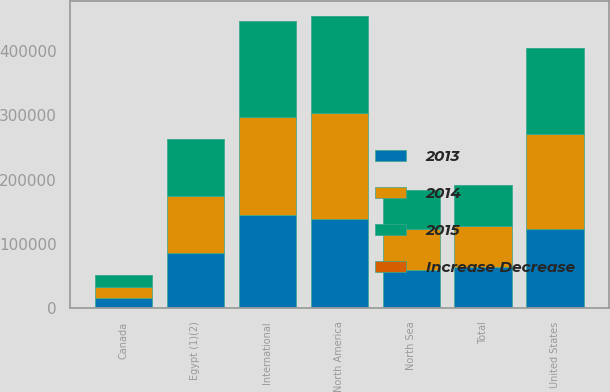<chart> <loc_0><loc_0><loc_500><loc_500><stacked_bar_chart><ecel><fcel>United States<fcel>Canada<fcel>North America<fcel>Egypt (1)(2)<fcel>North Sea<fcel>International<fcel>Total<nl><fcel>2013<fcel>123666<fcel>15768<fcel>139434<fcel>85589<fcel>59334<fcel>144923<fcel>63721<nl><fcel>Increase Decrease<fcel>7<fcel>10<fcel>8<fcel>3<fcel>2<fcel>2<fcel>5<nl><fcel>2015<fcel>133667<fcel>17593<fcel>151260<fcel>87917<fcel>60699<fcel>148616<fcel>63721<nl><fcel>2014<fcel>146907<fcel>17724<fcel>164631<fcel>89561<fcel>63721<fcel>153282<fcel>63721<nl></chart> 